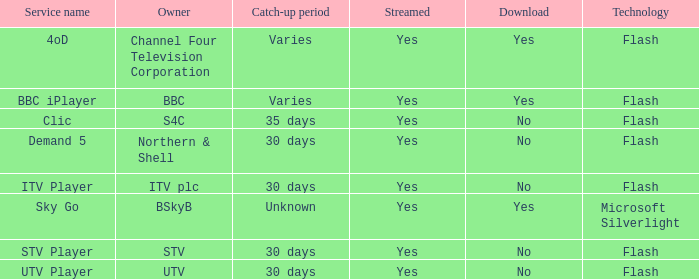What is the download of the varies catch-up period? Yes, Yes. 